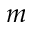Convert formula to latex. <formula><loc_0><loc_0><loc_500><loc_500>m</formula> 